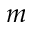Convert formula to latex. <formula><loc_0><loc_0><loc_500><loc_500>m</formula> 